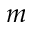Convert formula to latex. <formula><loc_0><loc_0><loc_500><loc_500>m</formula> 